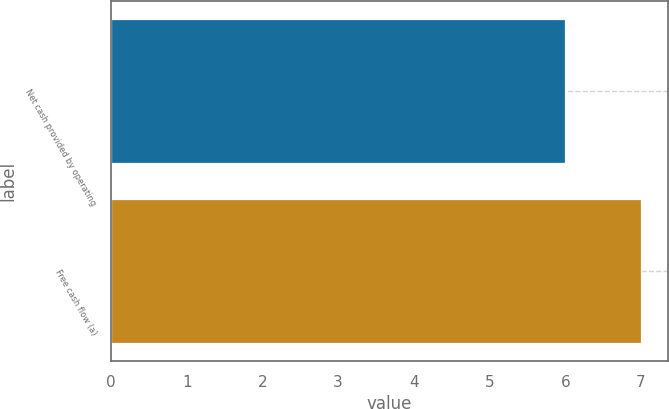Convert chart to OTSL. <chart><loc_0><loc_0><loc_500><loc_500><bar_chart><fcel>Net cash provided by operating<fcel>Free cash flow (a)<nl><fcel>6<fcel>7<nl></chart> 